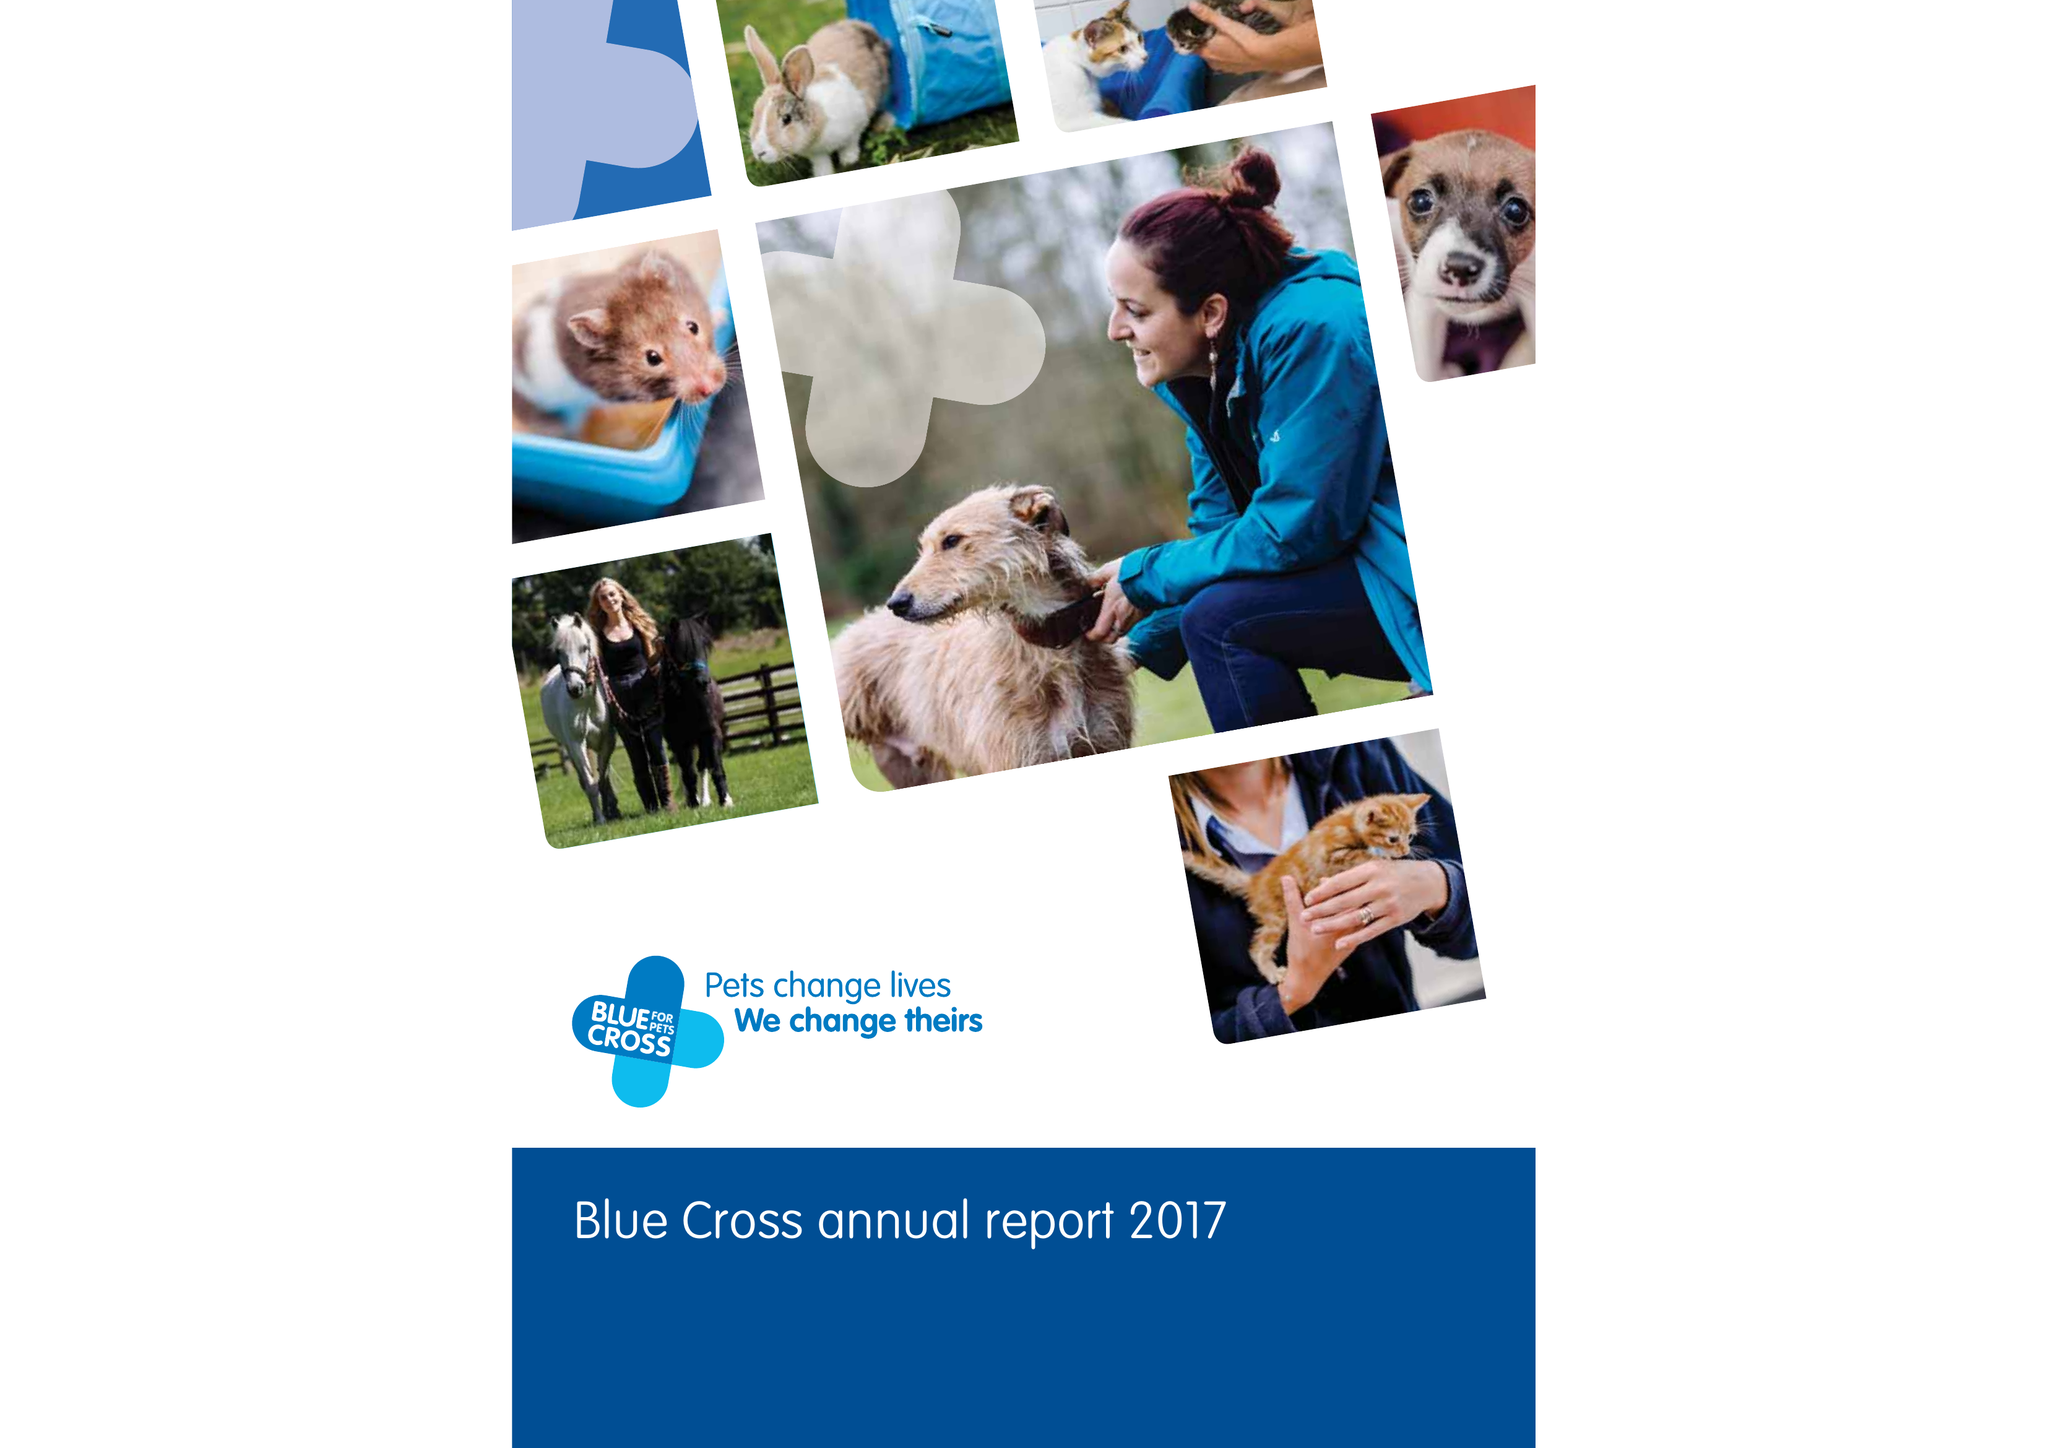What is the value for the spending_annually_in_british_pounds?
Answer the question using a single word or phrase. 37660000.00 